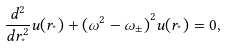<formula> <loc_0><loc_0><loc_500><loc_500>\frac { { d } ^ { 2 } } { d { r } _ { ^ { * } } ^ { 2 } } u ( { r } _ { ^ { * } } ) + { ( { \omega } ^ { 2 } - { \omega } _ { \pm } ) } ^ { 2 } u ( { r } _ { ^ { * } } ) = 0 ,</formula> 